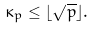Convert formula to latex. <formula><loc_0><loc_0><loc_500><loc_500>\kappa _ { p } \leq \lfloor \sqrt { p } \rfloor .</formula> 